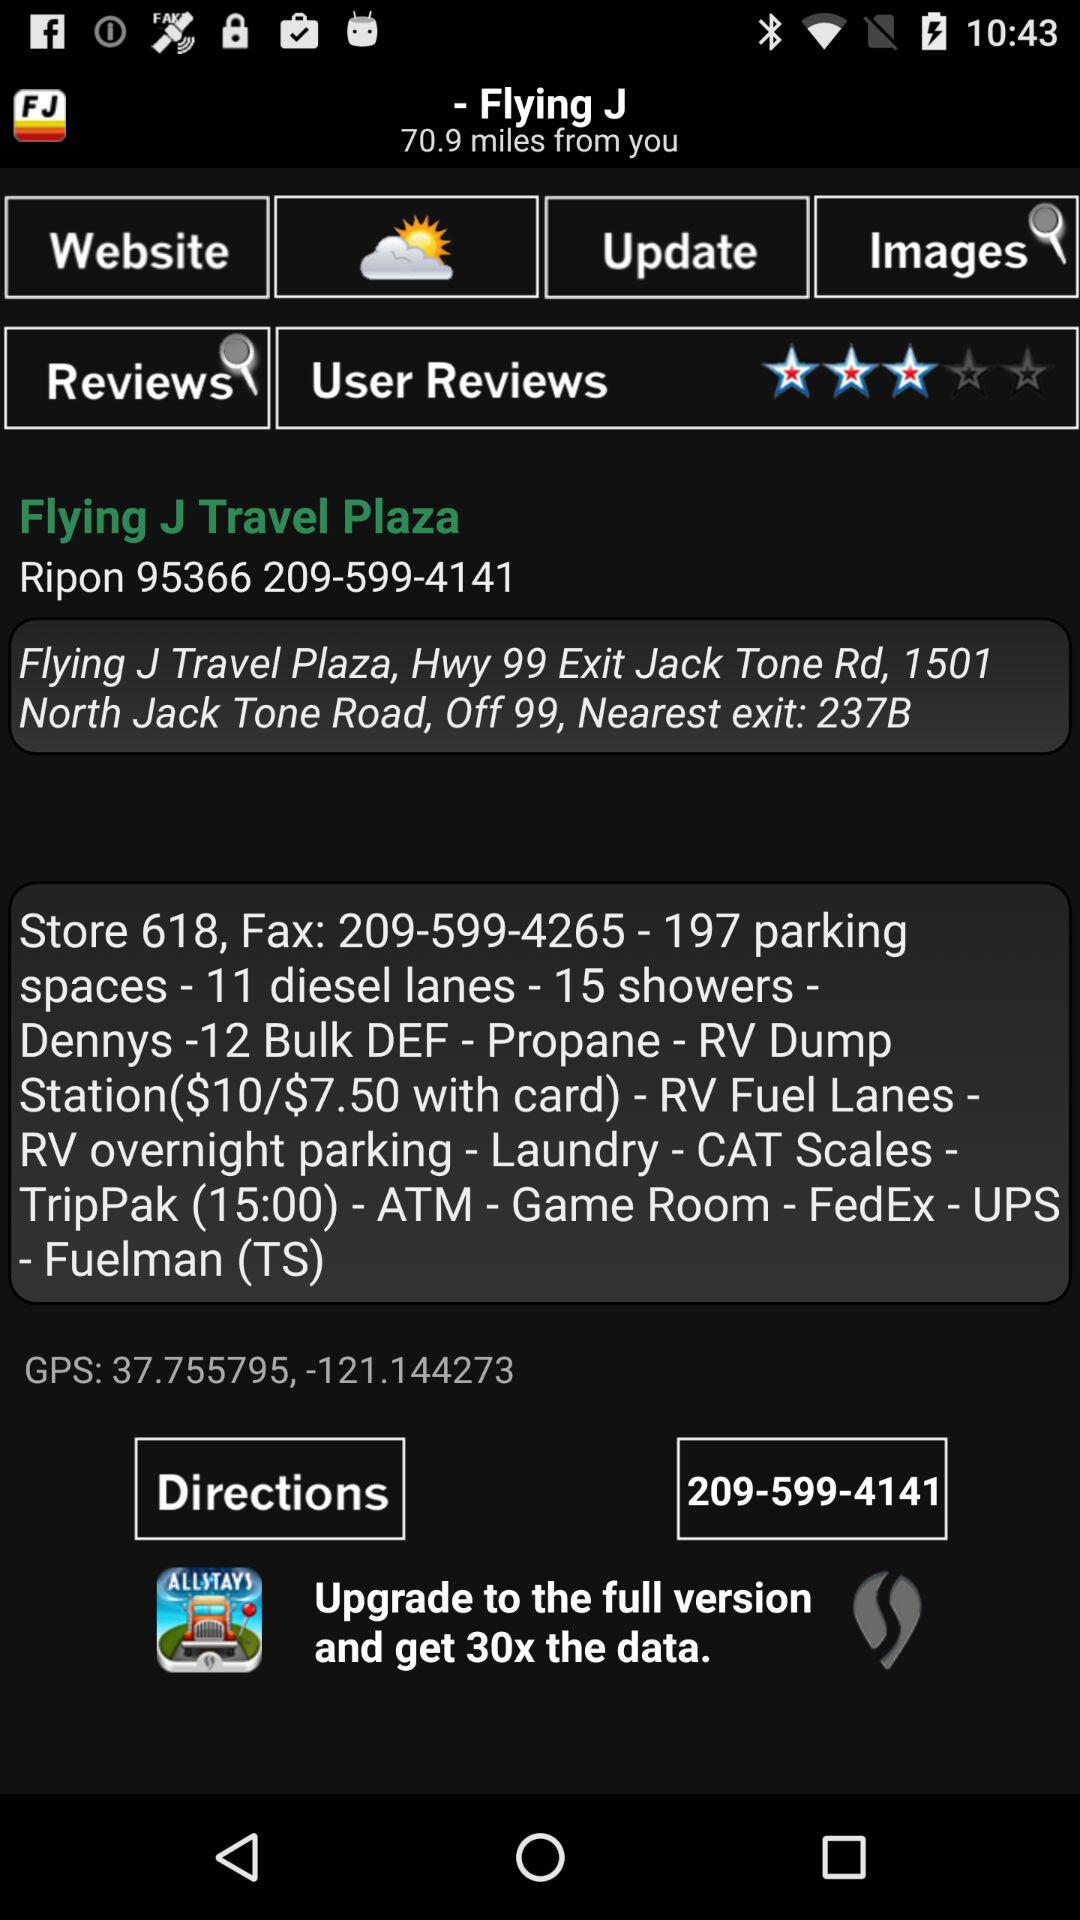What is the fax number for "Flying J Travel Plaza"? The fax number is 209-599-4265. 